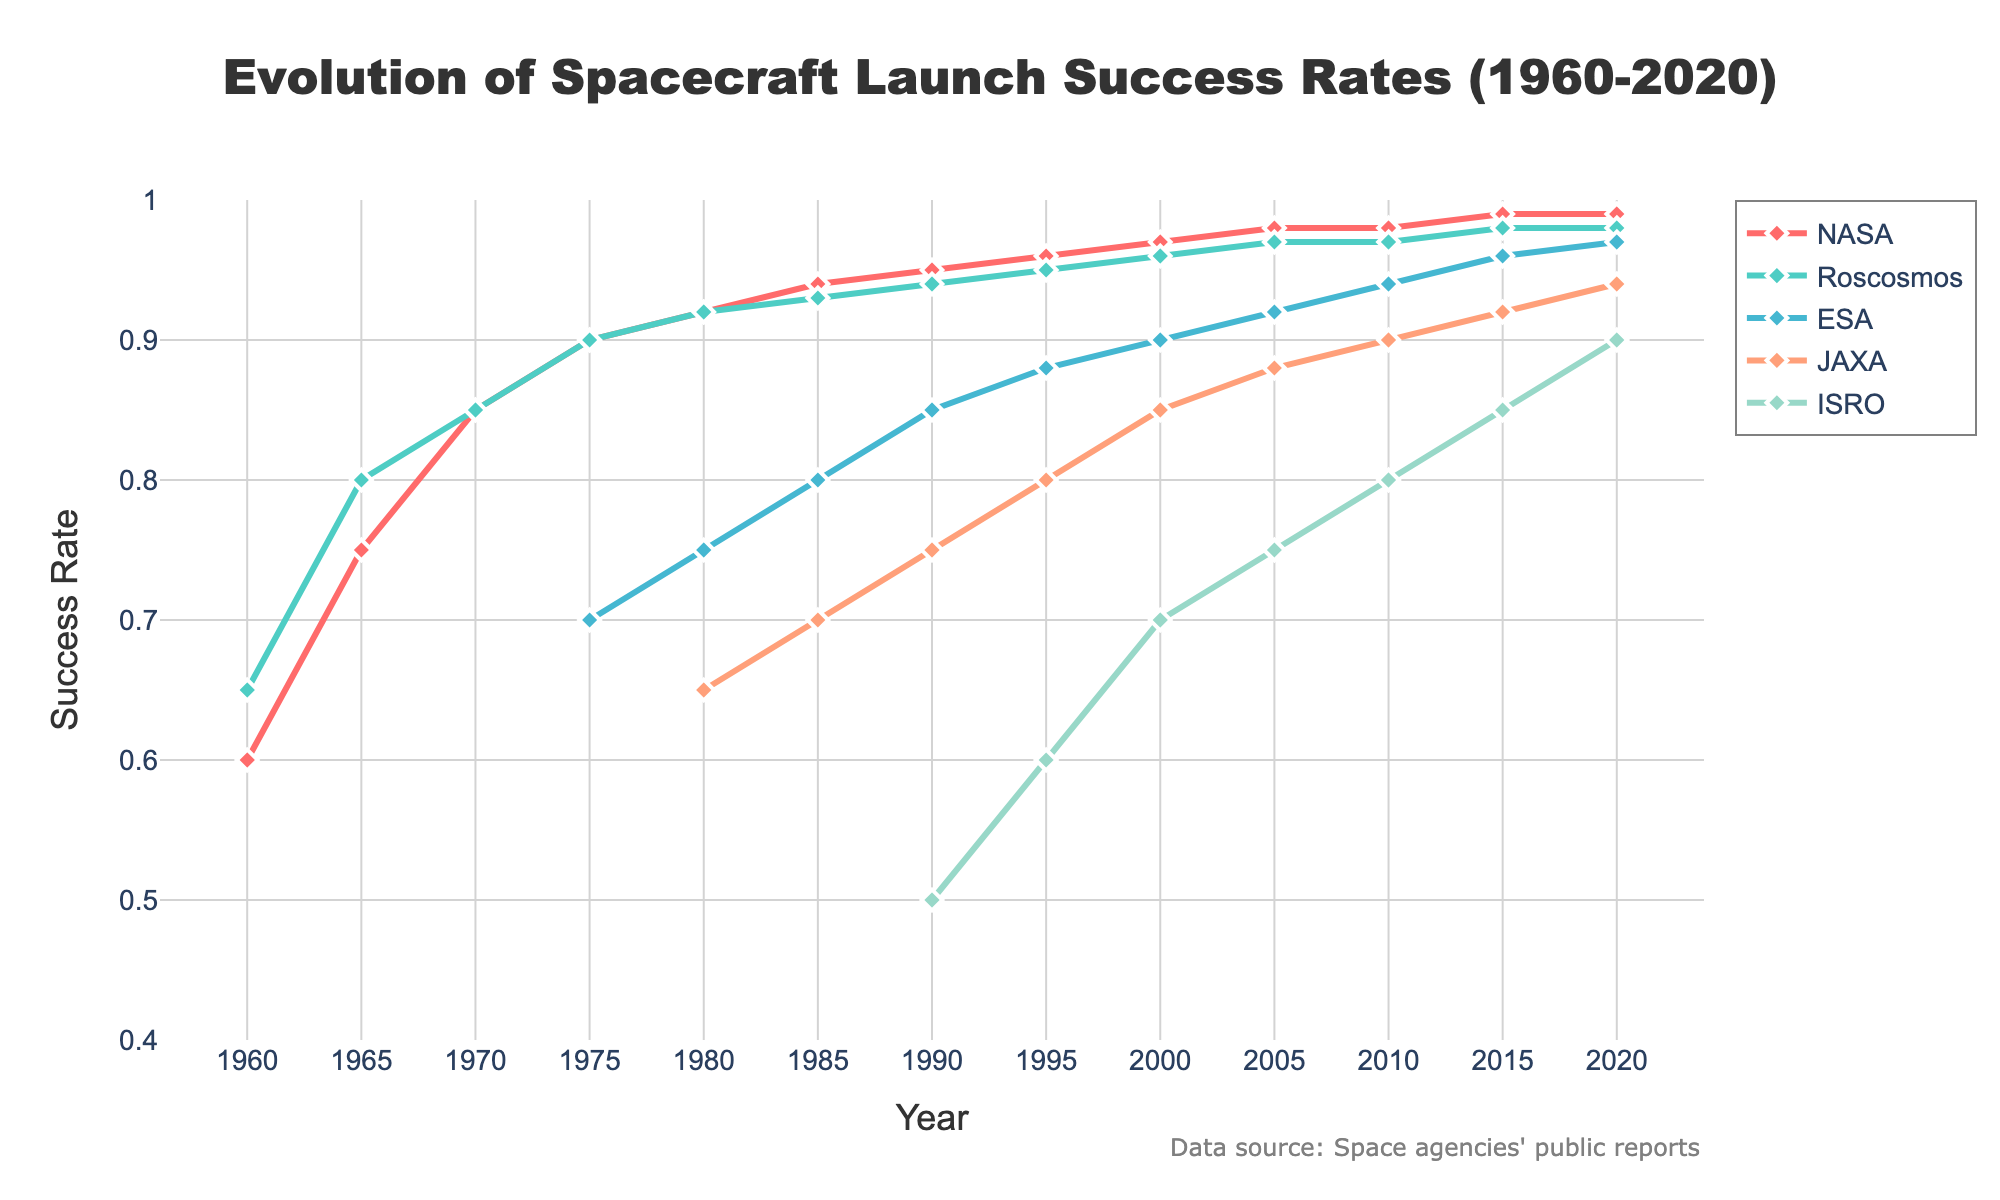What's the success rate of NASA in 1980? Look at the data point for NASA in the year 1980. The line representing NASA intersects with the vertical line at 1980. The value corresponding to this intersection is approximately 0.92.
Answer: 0.92 Which space agency had the highest success rate in 2020? Compare the success rates of all listed agencies in the year 2020. NASA, Roscosmos, ESA, JAXA, and ISRO are all above 0.9, but ESA has the highest success rate at 0.97.
Answer: ESA Between 1965 and 1975, which agency showed a bigger improvement in success rate, NASA or Roscosmos? Calculate the change in success rate for both NASA and Roscosmos between 1965 and 1975. For NASA, it's: 0.90 - 0.75 = 0.15. For Roscosmos, it's: 0.90 - 0.80 = 0.10.
Answer: NASA In which year did ESA first appear in the data? Look at the starting points of each agency's line on the chart. ESA's data line starts at 1975.
Answer: 1975 How did JAXA's success rate change from 1980 to 2000? Subtract JAXA's success rate in 1980 from that in 2000. The values are 0.65 and 0.85 respectively. So, the change is 0.85 - 0.65 = 0.20.
Answer: Increased by 0.20 Compare the success rate trends of NASA and ISRO between 1990 and 2020? Observe the slopes of the lines for NASA and ISRO between 1990 and 2020. NASA's success rate increases steadily, while ISRO's success rate increases more steeply over this period.
Answer: Both increased, but ISRO increased more steeply What is the average success rate of Roscosmos between 1960 and 2020? Calculate the average of Roscosmos' success rates for each listed year: (0.65 + 0.80 + 0.85 + 0.90 + 0.92 + 0.93 + 0.94 + 0.95 + 0.96 + 0.97 + 0.97 + 0.98 + 0.98) / 13. The sum is 11.70, and the average is 11.70 / 13 = 0.90.
Answer: 0.90 Check the visual attributes: What color represents ESA in the plot? Identify the color used for each agency in the plot based on the legend. ESA is represented by a greenish-blue or light blue color.
Answer: Light blue Quantify the gap between ISRO and JAXA's success rates in 2010 and 2020. First, find the success rates: In 2010, ISRO: 0.80 and JAXA: 0.90; In 2020, ISRO: 0.90 and JAXA: 0.94. The gaps are: In 2010, 0.90 - 0.80 = 0.10; In 2020, 0.94 - 0.90 = 0.04.
Answer: Decreased from 0.10 to 0.04 What's the overall trend of success rates for the value JAXA follows since 1980? Look closely at the line representing JAXA from 1980 onwards. It generally shows an upward trend, indicating improvement over the years.
Answer: An upward trend 